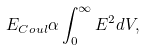<formula> <loc_0><loc_0><loc_500><loc_500>E _ { C o u l } \alpha \int _ { 0 } ^ { \infty } E ^ { 2 } d V ,</formula> 